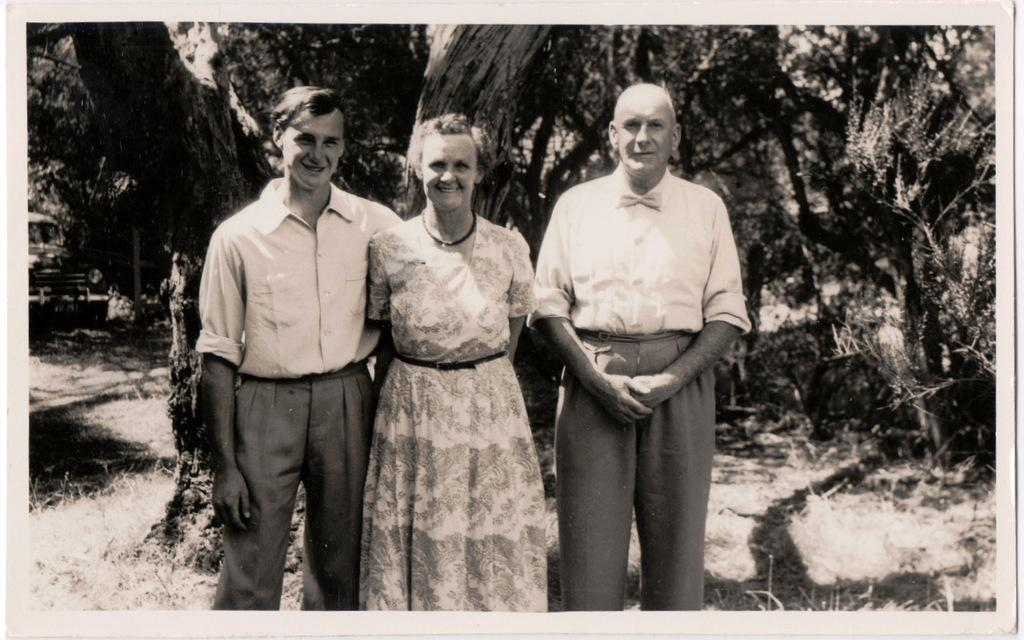What is the color scheme of the image? The image is black and white. How many people are in the image? There are three persons in the image. What is the facial expression of the people in the image? The persons are smiling. What type of vehicle is present in the image? There is a car in the image. What can be seen in the background of the image? There are trees in the background of the image. How many flags are visible in the image? There are no flags present in the image. What type of snakes can be seen slithering in the background of the image? There are no snakes visible in the image; it features trees in the background. 